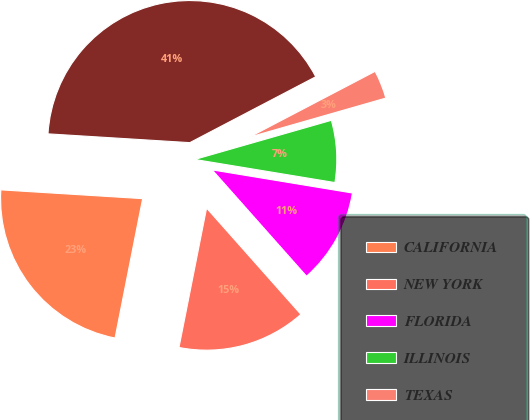Convert chart. <chart><loc_0><loc_0><loc_500><loc_500><pie_chart><fcel>CALIFORNIA<fcel>NEW YORK<fcel>FLORIDA<fcel>ILLINOIS<fcel>TEXAS<fcel>OTHERS<nl><fcel>22.87%<fcel>14.66%<fcel>10.85%<fcel>7.04%<fcel>3.23%<fcel>41.34%<nl></chart> 